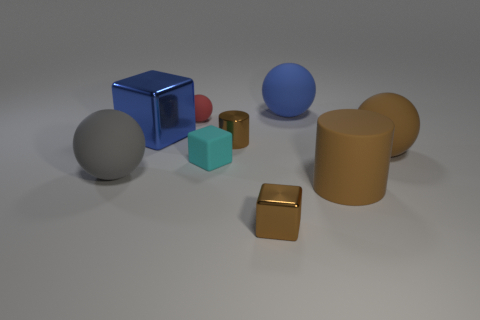Is the small cyan thing the same shape as the blue matte object? No, the small cyan object is a cube, whereas the blue matte object has a three-dimensional rectangular shape with more length in one dimension, making it a cuboid. 